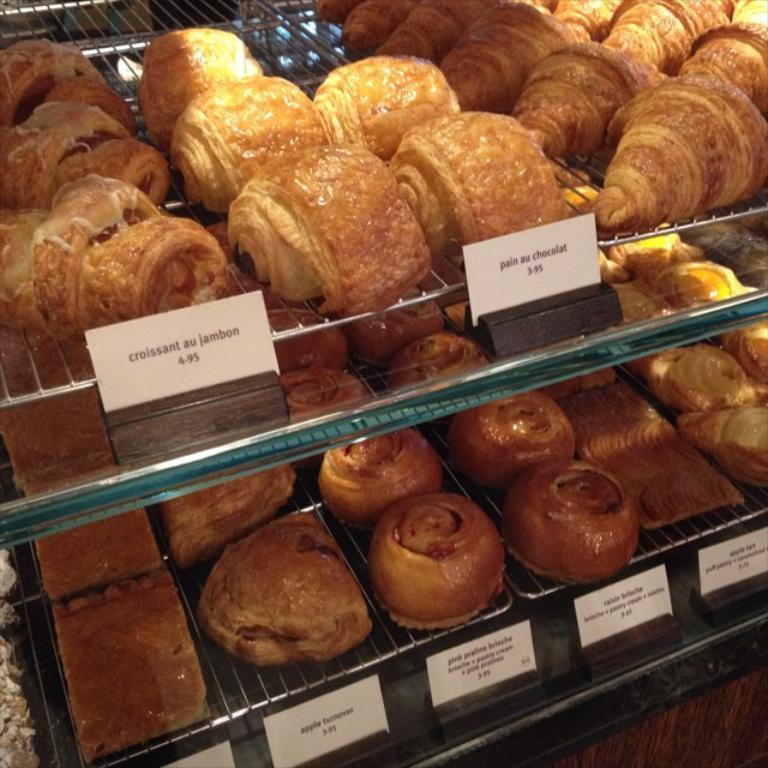What is the color of the food items visible in the image? The food items in the image are brown in color. What can be seen on the shelves in the image? There are paper boards on the shelves in the image. What is written on the paper boards? Something is written on the paper boards, but the specific content is not mentioned in the facts. How many crows are sitting on the chair in the image? There is no chair or crow present in the image. 